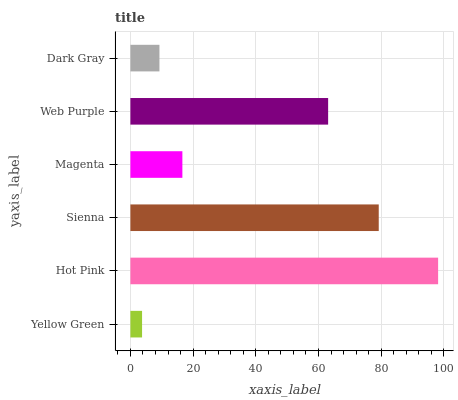Is Yellow Green the minimum?
Answer yes or no. Yes. Is Hot Pink the maximum?
Answer yes or no. Yes. Is Sienna the minimum?
Answer yes or no. No. Is Sienna the maximum?
Answer yes or no. No. Is Hot Pink greater than Sienna?
Answer yes or no. Yes. Is Sienna less than Hot Pink?
Answer yes or no. Yes. Is Sienna greater than Hot Pink?
Answer yes or no. No. Is Hot Pink less than Sienna?
Answer yes or no. No. Is Web Purple the high median?
Answer yes or no. Yes. Is Magenta the low median?
Answer yes or no. Yes. Is Sienna the high median?
Answer yes or no. No. Is Dark Gray the low median?
Answer yes or no. No. 